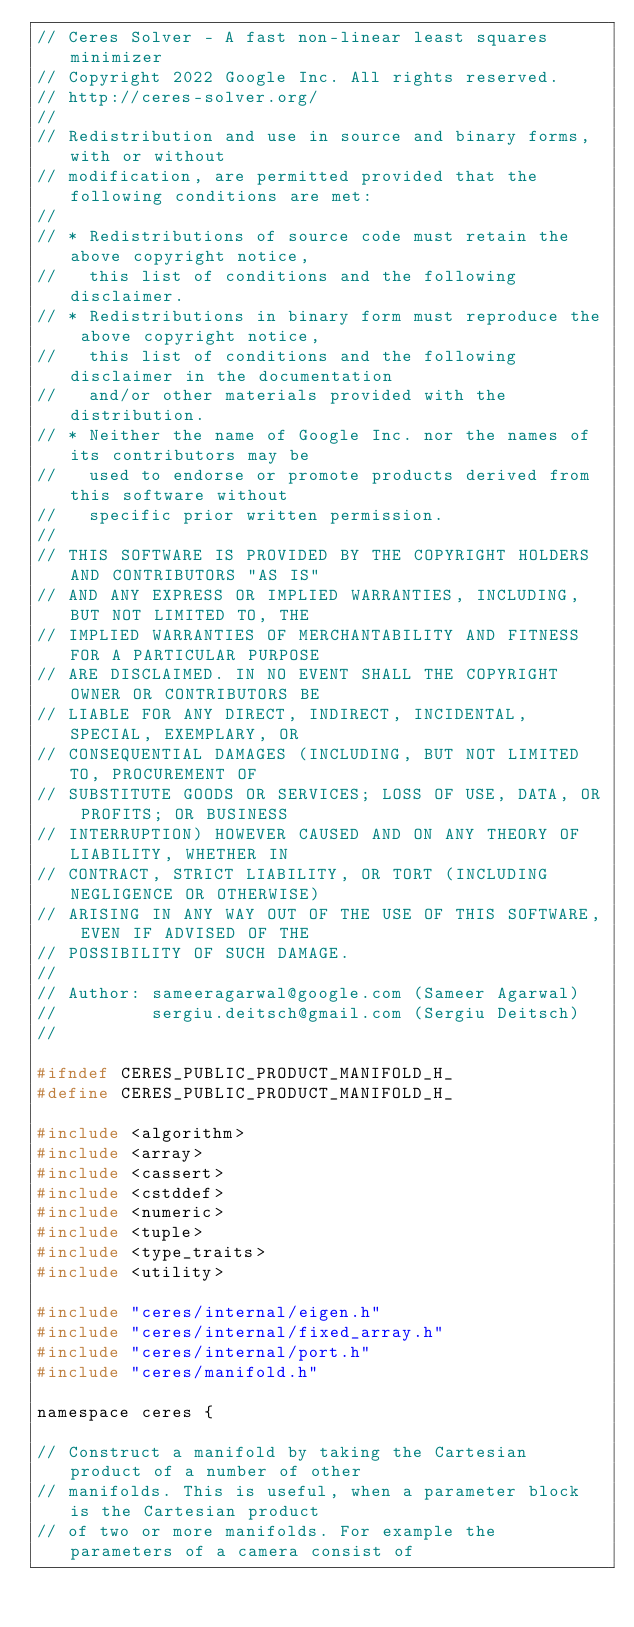Convert code to text. <code><loc_0><loc_0><loc_500><loc_500><_C_>// Ceres Solver - A fast non-linear least squares minimizer
// Copyright 2022 Google Inc. All rights reserved.
// http://ceres-solver.org/
//
// Redistribution and use in source and binary forms, with or without
// modification, are permitted provided that the following conditions are met:
//
// * Redistributions of source code must retain the above copyright notice,
//   this list of conditions and the following disclaimer.
// * Redistributions in binary form must reproduce the above copyright notice,
//   this list of conditions and the following disclaimer in the documentation
//   and/or other materials provided with the distribution.
// * Neither the name of Google Inc. nor the names of its contributors may be
//   used to endorse or promote products derived from this software without
//   specific prior written permission.
//
// THIS SOFTWARE IS PROVIDED BY THE COPYRIGHT HOLDERS AND CONTRIBUTORS "AS IS"
// AND ANY EXPRESS OR IMPLIED WARRANTIES, INCLUDING, BUT NOT LIMITED TO, THE
// IMPLIED WARRANTIES OF MERCHANTABILITY AND FITNESS FOR A PARTICULAR PURPOSE
// ARE DISCLAIMED. IN NO EVENT SHALL THE COPYRIGHT OWNER OR CONTRIBUTORS BE
// LIABLE FOR ANY DIRECT, INDIRECT, INCIDENTAL, SPECIAL, EXEMPLARY, OR
// CONSEQUENTIAL DAMAGES (INCLUDING, BUT NOT LIMITED TO, PROCUREMENT OF
// SUBSTITUTE GOODS OR SERVICES; LOSS OF USE, DATA, OR PROFITS; OR BUSINESS
// INTERRUPTION) HOWEVER CAUSED AND ON ANY THEORY OF LIABILITY, WHETHER IN
// CONTRACT, STRICT LIABILITY, OR TORT (INCLUDING NEGLIGENCE OR OTHERWISE)
// ARISING IN ANY WAY OUT OF THE USE OF THIS SOFTWARE, EVEN IF ADVISED OF THE
// POSSIBILITY OF SUCH DAMAGE.
//
// Author: sameeragarwal@google.com (Sameer Agarwal)
//         sergiu.deitsch@gmail.com (Sergiu Deitsch)
//

#ifndef CERES_PUBLIC_PRODUCT_MANIFOLD_H_
#define CERES_PUBLIC_PRODUCT_MANIFOLD_H_

#include <algorithm>
#include <array>
#include <cassert>
#include <cstddef>
#include <numeric>
#include <tuple>
#include <type_traits>
#include <utility>

#include "ceres/internal/eigen.h"
#include "ceres/internal/fixed_array.h"
#include "ceres/internal/port.h"
#include "ceres/manifold.h"

namespace ceres {

// Construct a manifold by taking the Cartesian product of a number of other
// manifolds. This is useful, when a parameter block is the Cartesian product
// of two or more manifolds. For example the parameters of a camera consist of</code> 